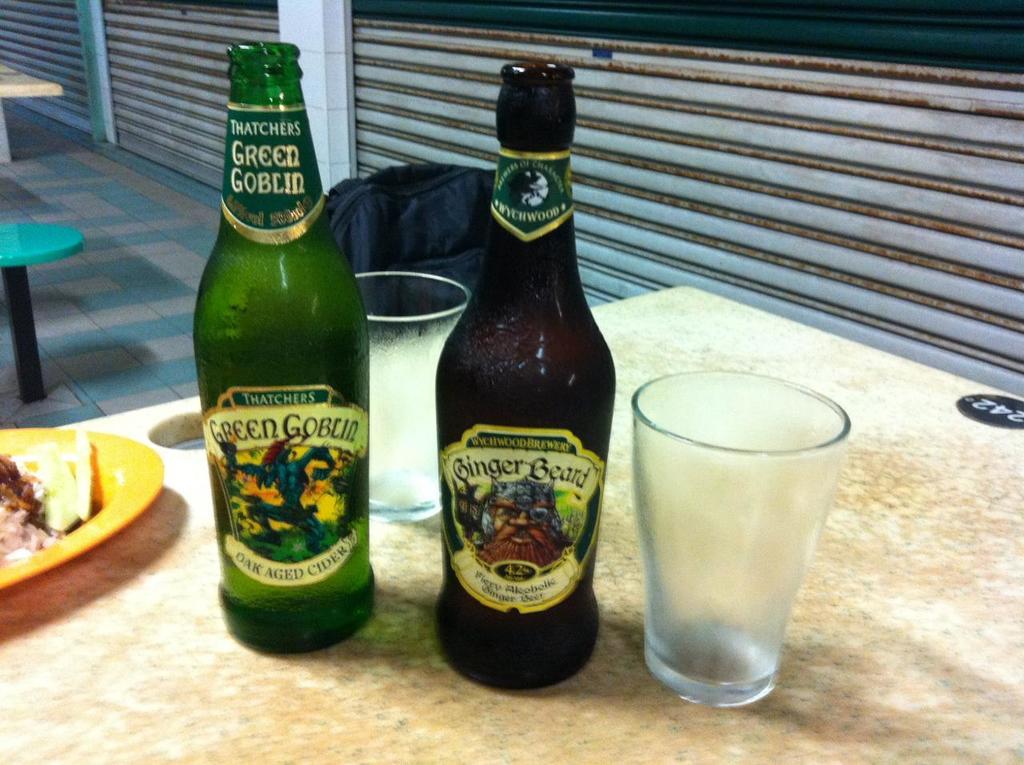What is the name of the aged cider?
Provide a short and direct response. Green goblin. What is the name of the beer on the left?
Make the answer very short. Green goblin. 